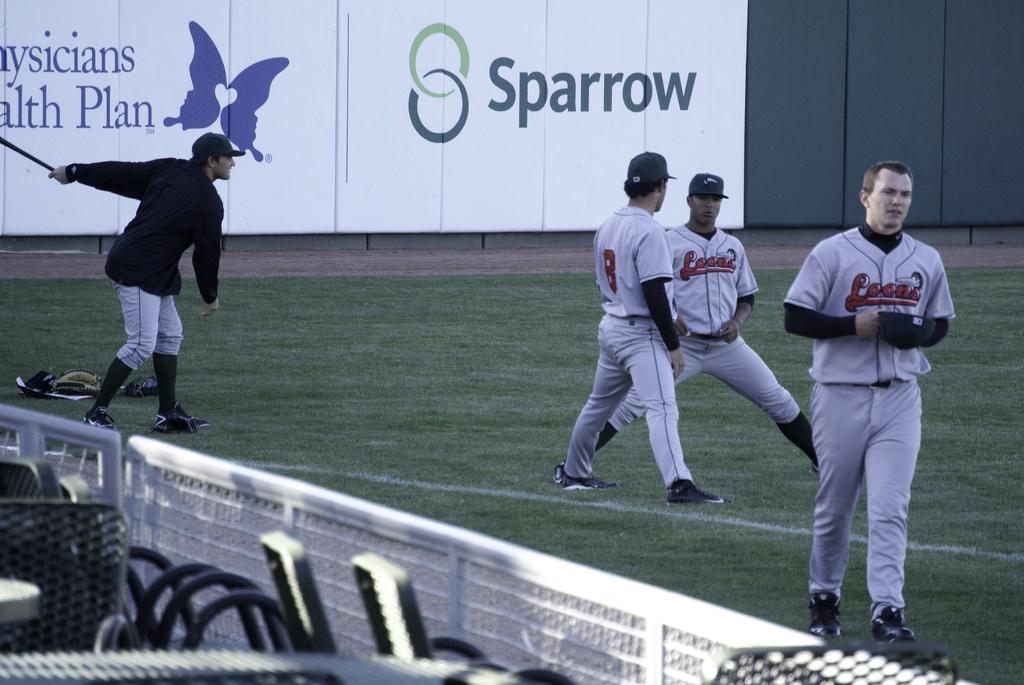What company logo that is also a type of bird printed on the board in the back?
Offer a very short reply. Sparrow. 